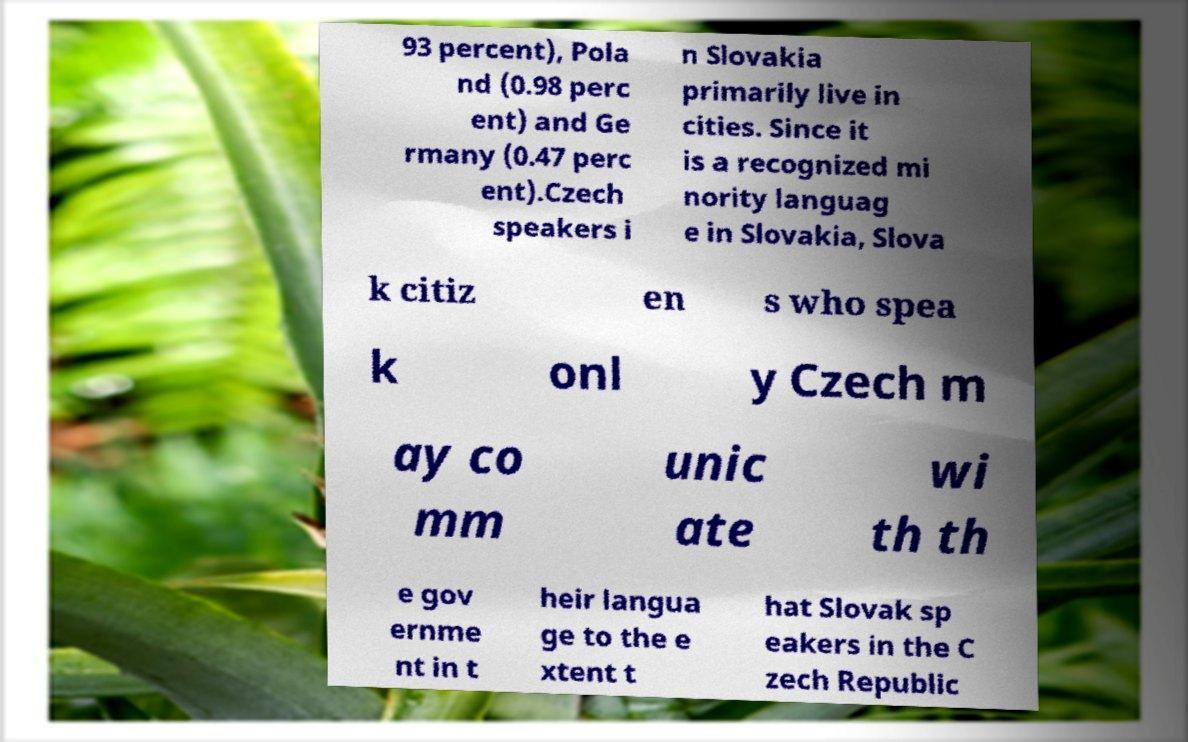Can you read and provide the text displayed in the image?This photo seems to have some interesting text. Can you extract and type it out for me? 93 percent), Pola nd (0.98 perc ent) and Ge rmany (0.47 perc ent).Czech speakers i n Slovakia primarily live in cities. Since it is a recognized mi nority languag e in Slovakia, Slova k citiz en s who spea k onl y Czech m ay co mm unic ate wi th th e gov ernme nt in t heir langua ge to the e xtent t hat Slovak sp eakers in the C zech Republic 